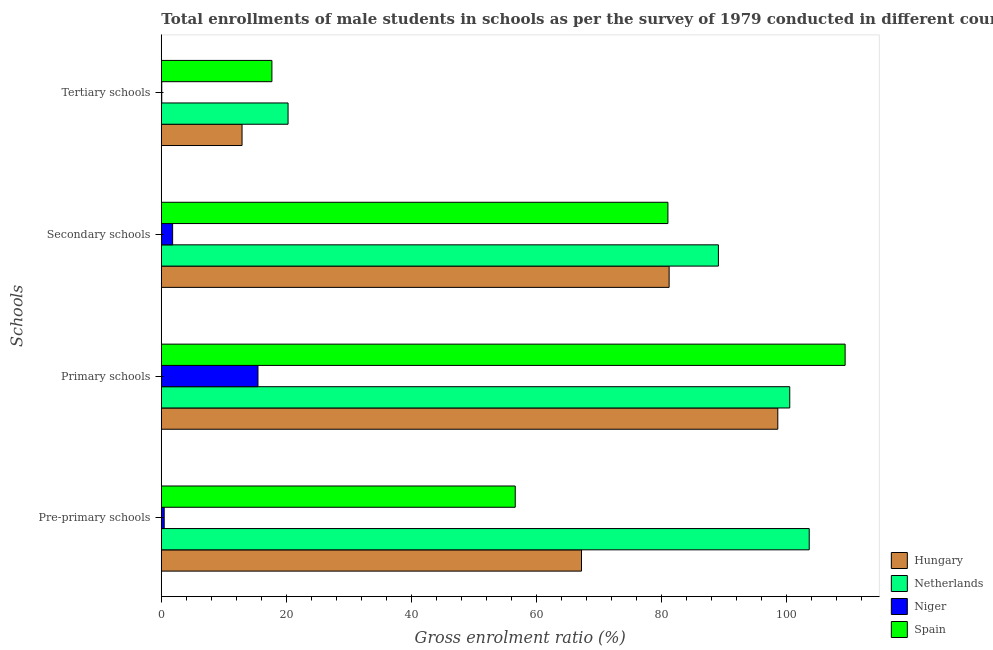How many different coloured bars are there?
Your answer should be compact. 4. Are the number of bars per tick equal to the number of legend labels?
Your response must be concise. Yes. How many bars are there on the 1st tick from the top?
Your answer should be very brief. 4. What is the label of the 4th group of bars from the top?
Offer a terse response. Pre-primary schools. What is the gross enrolment ratio(male) in primary schools in Netherlands?
Offer a very short reply. 100.51. Across all countries, what is the maximum gross enrolment ratio(male) in pre-primary schools?
Your response must be concise. 103.62. Across all countries, what is the minimum gross enrolment ratio(male) in primary schools?
Offer a terse response. 15.46. In which country was the gross enrolment ratio(male) in pre-primary schools maximum?
Provide a succinct answer. Netherlands. In which country was the gross enrolment ratio(male) in tertiary schools minimum?
Your answer should be very brief. Niger. What is the total gross enrolment ratio(male) in tertiary schools in the graph?
Offer a terse response. 50.94. What is the difference between the gross enrolment ratio(male) in primary schools in Netherlands and that in Niger?
Make the answer very short. 85.05. What is the difference between the gross enrolment ratio(male) in secondary schools in Spain and the gross enrolment ratio(male) in primary schools in Hungary?
Offer a very short reply. -17.57. What is the average gross enrolment ratio(male) in pre-primary schools per country?
Provide a succinct answer. 56.97. What is the difference between the gross enrolment ratio(male) in secondary schools and gross enrolment ratio(male) in primary schools in Netherlands?
Make the answer very short. -11.41. In how many countries, is the gross enrolment ratio(male) in secondary schools greater than 24 %?
Offer a terse response. 3. What is the ratio of the gross enrolment ratio(male) in secondary schools in Hungary to that in Netherlands?
Ensure brevity in your answer.  0.91. Is the gross enrolment ratio(male) in pre-primary schools in Hungary less than that in Niger?
Offer a very short reply. No. What is the difference between the highest and the second highest gross enrolment ratio(male) in tertiary schools?
Your answer should be very brief. 2.58. What is the difference between the highest and the lowest gross enrolment ratio(male) in tertiary schools?
Offer a very short reply. 20.2. In how many countries, is the gross enrolment ratio(male) in tertiary schools greater than the average gross enrolment ratio(male) in tertiary schools taken over all countries?
Your response must be concise. 3. Is the sum of the gross enrolment ratio(male) in pre-primary schools in Hungary and Netherlands greater than the maximum gross enrolment ratio(male) in secondary schools across all countries?
Your answer should be compact. Yes. What does the 3rd bar from the top in Secondary schools represents?
Provide a short and direct response. Netherlands. What does the 2nd bar from the bottom in Tertiary schools represents?
Give a very brief answer. Netherlands. How many bars are there?
Ensure brevity in your answer.  16. How many countries are there in the graph?
Give a very brief answer. 4. Does the graph contain any zero values?
Your answer should be very brief. No. Does the graph contain grids?
Give a very brief answer. No. Where does the legend appear in the graph?
Ensure brevity in your answer.  Bottom right. How many legend labels are there?
Your answer should be very brief. 4. What is the title of the graph?
Your answer should be very brief. Total enrollments of male students in schools as per the survey of 1979 conducted in different countries. Does "Denmark" appear as one of the legend labels in the graph?
Provide a short and direct response. No. What is the label or title of the Y-axis?
Give a very brief answer. Schools. What is the Gross enrolment ratio (%) in Hungary in Pre-primary schools?
Provide a succinct answer. 67.2. What is the Gross enrolment ratio (%) of Netherlands in Pre-primary schools?
Your answer should be compact. 103.62. What is the Gross enrolment ratio (%) of Niger in Pre-primary schools?
Offer a very short reply. 0.46. What is the Gross enrolment ratio (%) in Spain in Pre-primary schools?
Offer a very short reply. 56.6. What is the Gross enrolment ratio (%) in Hungary in Primary schools?
Your answer should be very brief. 98.6. What is the Gross enrolment ratio (%) of Netherlands in Primary schools?
Make the answer very short. 100.51. What is the Gross enrolment ratio (%) of Niger in Primary schools?
Provide a succinct answer. 15.46. What is the Gross enrolment ratio (%) in Spain in Primary schools?
Keep it short and to the point. 109.36. What is the Gross enrolment ratio (%) in Hungary in Secondary schools?
Your response must be concise. 81.22. What is the Gross enrolment ratio (%) of Netherlands in Secondary schools?
Your answer should be compact. 89.1. What is the Gross enrolment ratio (%) in Niger in Secondary schools?
Provide a short and direct response. 1.81. What is the Gross enrolment ratio (%) in Spain in Secondary schools?
Make the answer very short. 81.02. What is the Gross enrolment ratio (%) in Hungary in Tertiary schools?
Ensure brevity in your answer.  12.91. What is the Gross enrolment ratio (%) of Netherlands in Tertiary schools?
Make the answer very short. 20.27. What is the Gross enrolment ratio (%) of Niger in Tertiary schools?
Make the answer very short. 0.07. What is the Gross enrolment ratio (%) in Spain in Tertiary schools?
Keep it short and to the point. 17.69. Across all Schools, what is the maximum Gross enrolment ratio (%) of Hungary?
Your answer should be very brief. 98.6. Across all Schools, what is the maximum Gross enrolment ratio (%) in Netherlands?
Your response must be concise. 103.62. Across all Schools, what is the maximum Gross enrolment ratio (%) of Niger?
Your response must be concise. 15.46. Across all Schools, what is the maximum Gross enrolment ratio (%) of Spain?
Offer a terse response. 109.36. Across all Schools, what is the minimum Gross enrolment ratio (%) of Hungary?
Your response must be concise. 12.91. Across all Schools, what is the minimum Gross enrolment ratio (%) in Netherlands?
Make the answer very short. 20.27. Across all Schools, what is the minimum Gross enrolment ratio (%) in Niger?
Give a very brief answer. 0.07. Across all Schools, what is the minimum Gross enrolment ratio (%) of Spain?
Your answer should be compact. 17.69. What is the total Gross enrolment ratio (%) of Hungary in the graph?
Offer a terse response. 259.93. What is the total Gross enrolment ratio (%) in Netherlands in the graph?
Your response must be concise. 313.5. What is the total Gross enrolment ratio (%) in Niger in the graph?
Give a very brief answer. 17.8. What is the total Gross enrolment ratio (%) in Spain in the graph?
Ensure brevity in your answer.  264.68. What is the difference between the Gross enrolment ratio (%) of Hungary in Pre-primary schools and that in Primary schools?
Provide a short and direct response. -31.39. What is the difference between the Gross enrolment ratio (%) in Netherlands in Pre-primary schools and that in Primary schools?
Make the answer very short. 3.12. What is the difference between the Gross enrolment ratio (%) of Niger in Pre-primary schools and that in Primary schools?
Make the answer very short. -15. What is the difference between the Gross enrolment ratio (%) in Spain in Pre-primary schools and that in Primary schools?
Your answer should be very brief. -52.76. What is the difference between the Gross enrolment ratio (%) in Hungary in Pre-primary schools and that in Secondary schools?
Ensure brevity in your answer.  -14.01. What is the difference between the Gross enrolment ratio (%) of Netherlands in Pre-primary schools and that in Secondary schools?
Your answer should be compact. 14.53. What is the difference between the Gross enrolment ratio (%) in Niger in Pre-primary schools and that in Secondary schools?
Offer a very short reply. -1.35. What is the difference between the Gross enrolment ratio (%) in Spain in Pre-primary schools and that in Secondary schools?
Keep it short and to the point. -24.42. What is the difference between the Gross enrolment ratio (%) in Hungary in Pre-primary schools and that in Tertiary schools?
Keep it short and to the point. 54.29. What is the difference between the Gross enrolment ratio (%) in Netherlands in Pre-primary schools and that in Tertiary schools?
Offer a very short reply. 83.35. What is the difference between the Gross enrolment ratio (%) in Niger in Pre-primary schools and that in Tertiary schools?
Ensure brevity in your answer.  0.39. What is the difference between the Gross enrolment ratio (%) of Spain in Pre-primary schools and that in Tertiary schools?
Your response must be concise. 38.92. What is the difference between the Gross enrolment ratio (%) in Hungary in Primary schools and that in Secondary schools?
Your response must be concise. 17.38. What is the difference between the Gross enrolment ratio (%) of Netherlands in Primary schools and that in Secondary schools?
Ensure brevity in your answer.  11.41. What is the difference between the Gross enrolment ratio (%) of Niger in Primary schools and that in Secondary schools?
Keep it short and to the point. 13.65. What is the difference between the Gross enrolment ratio (%) of Spain in Primary schools and that in Secondary schools?
Provide a succinct answer. 28.34. What is the difference between the Gross enrolment ratio (%) of Hungary in Primary schools and that in Tertiary schools?
Give a very brief answer. 85.68. What is the difference between the Gross enrolment ratio (%) of Netherlands in Primary schools and that in Tertiary schools?
Keep it short and to the point. 80.24. What is the difference between the Gross enrolment ratio (%) in Niger in Primary schools and that in Tertiary schools?
Your answer should be very brief. 15.39. What is the difference between the Gross enrolment ratio (%) in Spain in Primary schools and that in Tertiary schools?
Keep it short and to the point. 91.68. What is the difference between the Gross enrolment ratio (%) of Hungary in Secondary schools and that in Tertiary schools?
Keep it short and to the point. 68.3. What is the difference between the Gross enrolment ratio (%) in Netherlands in Secondary schools and that in Tertiary schools?
Your answer should be compact. 68.83. What is the difference between the Gross enrolment ratio (%) in Niger in Secondary schools and that in Tertiary schools?
Your response must be concise. 1.74. What is the difference between the Gross enrolment ratio (%) in Spain in Secondary schools and that in Tertiary schools?
Ensure brevity in your answer.  63.33. What is the difference between the Gross enrolment ratio (%) of Hungary in Pre-primary schools and the Gross enrolment ratio (%) of Netherlands in Primary schools?
Provide a short and direct response. -33.3. What is the difference between the Gross enrolment ratio (%) in Hungary in Pre-primary schools and the Gross enrolment ratio (%) in Niger in Primary schools?
Provide a short and direct response. 51.74. What is the difference between the Gross enrolment ratio (%) of Hungary in Pre-primary schools and the Gross enrolment ratio (%) of Spain in Primary schools?
Give a very brief answer. -42.16. What is the difference between the Gross enrolment ratio (%) of Netherlands in Pre-primary schools and the Gross enrolment ratio (%) of Niger in Primary schools?
Offer a terse response. 88.16. What is the difference between the Gross enrolment ratio (%) of Netherlands in Pre-primary schools and the Gross enrolment ratio (%) of Spain in Primary schools?
Your answer should be compact. -5.74. What is the difference between the Gross enrolment ratio (%) in Niger in Pre-primary schools and the Gross enrolment ratio (%) in Spain in Primary schools?
Provide a short and direct response. -108.9. What is the difference between the Gross enrolment ratio (%) of Hungary in Pre-primary schools and the Gross enrolment ratio (%) of Netherlands in Secondary schools?
Provide a short and direct response. -21.9. What is the difference between the Gross enrolment ratio (%) of Hungary in Pre-primary schools and the Gross enrolment ratio (%) of Niger in Secondary schools?
Your response must be concise. 65.39. What is the difference between the Gross enrolment ratio (%) of Hungary in Pre-primary schools and the Gross enrolment ratio (%) of Spain in Secondary schools?
Make the answer very short. -13.82. What is the difference between the Gross enrolment ratio (%) in Netherlands in Pre-primary schools and the Gross enrolment ratio (%) in Niger in Secondary schools?
Keep it short and to the point. 101.81. What is the difference between the Gross enrolment ratio (%) in Netherlands in Pre-primary schools and the Gross enrolment ratio (%) in Spain in Secondary schools?
Your answer should be compact. 22.6. What is the difference between the Gross enrolment ratio (%) in Niger in Pre-primary schools and the Gross enrolment ratio (%) in Spain in Secondary schools?
Provide a short and direct response. -80.56. What is the difference between the Gross enrolment ratio (%) of Hungary in Pre-primary schools and the Gross enrolment ratio (%) of Netherlands in Tertiary schools?
Keep it short and to the point. 46.93. What is the difference between the Gross enrolment ratio (%) in Hungary in Pre-primary schools and the Gross enrolment ratio (%) in Niger in Tertiary schools?
Provide a short and direct response. 67.13. What is the difference between the Gross enrolment ratio (%) in Hungary in Pre-primary schools and the Gross enrolment ratio (%) in Spain in Tertiary schools?
Keep it short and to the point. 49.51. What is the difference between the Gross enrolment ratio (%) of Netherlands in Pre-primary schools and the Gross enrolment ratio (%) of Niger in Tertiary schools?
Keep it short and to the point. 103.55. What is the difference between the Gross enrolment ratio (%) of Netherlands in Pre-primary schools and the Gross enrolment ratio (%) of Spain in Tertiary schools?
Ensure brevity in your answer.  85.93. What is the difference between the Gross enrolment ratio (%) of Niger in Pre-primary schools and the Gross enrolment ratio (%) of Spain in Tertiary schools?
Make the answer very short. -17.23. What is the difference between the Gross enrolment ratio (%) of Hungary in Primary schools and the Gross enrolment ratio (%) of Netherlands in Secondary schools?
Keep it short and to the point. 9.5. What is the difference between the Gross enrolment ratio (%) in Hungary in Primary schools and the Gross enrolment ratio (%) in Niger in Secondary schools?
Give a very brief answer. 96.79. What is the difference between the Gross enrolment ratio (%) in Hungary in Primary schools and the Gross enrolment ratio (%) in Spain in Secondary schools?
Keep it short and to the point. 17.57. What is the difference between the Gross enrolment ratio (%) of Netherlands in Primary schools and the Gross enrolment ratio (%) of Niger in Secondary schools?
Ensure brevity in your answer.  98.7. What is the difference between the Gross enrolment ratio (%) of Netherlands in Primary schools and the Gross enrolment ratio (%) of Spain in Secondary schools?
Give a very brief answer. 19.49. What is the difference between the Gross enrolment ratio (%) of Niger in Primary schools and the Gross enrolment ratio (%) of Spain in Secondary schools?
Your response must be concise. -65.56. What is the difference between the Gross enrolment ratio (%) in Hungary in Primary schools and the Gross enrolment ratio (%) in Netherlands in Tertiary schools?
Make the answer very short. 78.32. What is the difference between the Gross enrolment ratio (%) of Hungary in Primary schools and the Gross enrolment ratio (%) of Niger in Tertiary schools?
Make the answer very short. 98.53. What is the difference between the Gross enrolment ratio (%) of Hungary in Primary schools and the Gross enrolment ratio (%) of Spain in Tertiary schools?
Provide a succinct answer. 80.91. What is the difference between the Gross enrolment ratio (%) of Netherlands in Primary schools and the Gross enrolment ratio (%) of Niger in Tertiary schools?
Your answer should be compact. 100.44. What is the difference between the Gross enrolment ratio (%) in Netherlands in Primary schools and the Gross enrolment ratio (%) in Spain in Tertiary schools?
Provide a succinct answer. 82.82. What is the difference between the Gross enrolment ratio (%) of Niger in Primary schools and the Gross enrolment ratio (%) of Spain in Tertiary schools?
Ensure brevity in your answer.  -2.23. What is the difference between the Gross enrolment ratio (%) in Hungary in Secondary schools and the Gross enrolment ratio (%) in Netherlands in Tertiary schools?
Your answer should be very brief. 60.95. What is the difference between the Gross enrolment ratio (%) of Hungary in Secondary schools and the Gross enrolment ratio (%) of Niger in Tertiary schools?
Make the answer very short. 81.15. What is the difference between the Gross enrolment ratio (%) of Hungary in Secondary schools and the Gross enrolment ratio (%) of Spain in Tertiary schools?
Make the answer very short. 63.53. What is the difference between the Gross enrolment ratio (%) in Netherlands in Secondary schools and the Gross enrolment ratio (%) in Niger in Tertiary schools?
Your response must be concise. 89.03. What is the difference between the Gross enrolment ratio (%) in Netherlands in Secondary schools and the Gross enrolment ratio (%) in Spain in Tertiary schools?
Ensure brevity in your answer.  71.41. What is the difference between the Gross enrolment ratio (%) in Niger in Secondary schools and the Gross enrolment ratio (%) in Spain in Tertiary schools?
Your answer should be very brief. -15.88. What is the average Gross enrolment ratio (%) of Hungary per Schools?
Your answer should be compact. 64.98. What is the average Gross enrolment ratio (%) in Netherlands per Schools?
Your answer should be compact. 78.37. What is the average Gross enrolment ratio (%) in Niger per Schools?
Offer a very short reply. 4.45. What is the average Gross enrolment ratio (%) of Spain per Schools?
Make the answer very short. 66.17. What is the difference between the Gross enrolment ratio (%) in Hungary and Gross enrolment ratio (%) in Netherlands in Pre-primary schools?
Make the answer very short. -36.42. What is the difference between the Gross enrolment ratio (%) of Hungary and Gross enrolment ratio (%) of Niger in Pre-primary schools?
Offer a very short reply. 66.74. What is the difference between the Gross enrolment ratio (%) in Hungary and Gross enrolment ratio (%) in Spain in Pre-primary schools?
Your answer should be very brief. 10.6. What is the difference between the Gross enrolment ratio (%) of Netherlands and Gross enrolment ratio (%) of Niger in Pre-primary schools?
Provide a succinct answer. 103.16. What is the difference between the Gross enrolment ratio (%) of Netherlands and Gross enrolment ratio (%) of Spain in Pre-primary schools?
Give a very brief answer. 47.02. What is the difference between the Gross enrolment ratio (%) in Niger and Gross enrolment ratio (%) in Spain in Pre-primary schools?
Ensure brevity in your answer.  -56.14. What is the difference between the Gross enrolment ratio (%) of Hungary and Gross enrolment ratio (%) of Netherlands in Primary schools?
Make the answer very short. -1.91. What is the difference between the Gross enrolment ratio (%) of Hungary and Gross enrolment ratio (%) of Niger in Primary schools?
Your response must be concise. 83.14. What is the difference between the Gross enrolment ratio (%) in Hungary and Gross enrolment ratio (%) in Spain in Primary schools?
Offer a very short reply. -10.77. What is the difference between the Gross enrolment ratio (%) of Netherlands and Gross enrolment ratio (%) of Niger in Primary schools?
Provide a succinct answer. 85.05. What is the difference between the Gross enrolment ratio (%) in Netherlands and Gross enrolment ratio (%) in Spain in Primary schools?
Your answer should be compact. -8.86. What is the difference between the Gross enrolment ratio (%) of Niger and Gross enrolment ratio (%) of Spain in Primary schools?
Keep it short and to the point. -93.91. What is the difference between the Gross enrolment ratio (%) in Hungary and Gross enrolment ratio (%) in Netherlands in Secondary schools?
Your answer should be very brief. -7.88. What is the difference between the Gross enrolment ratio (%) of Hungary and Gross enrolment ratio (%) of Niger in Secondary schools?
Your answer should be compact. 79.41. What is the difference between the Gross enrolment ratio (%) of Hungary and Gross enrolment ratio (%) of Spain in Secondary schools?
Your answer should be very brief. 0.2. What is the difference between the Gross enrolment ratio (%) in Netherlands and Gross enrolment ratio (%) in Niger in Secondary schools?
Give a very brief answer. 87.29. What is the difference between the Gross enrolment ratio (%) of Netherlands and Gross enrolment ratio (%) of Spain in Secondary schools?
Provide a succinct answer. 8.08. What is the difference between the Gross enrolment ratio (%) in Niger and Gross enrolment ratio (%) in Spain in Secondary schools?
Your answer should be very brief. -79.21. What is the difference between the Gross enrolment ratio (%) of Hungary and Gross enrolment ratio (%) of Netherlands in Tertiary schools?
Your response must be concise. -7.36. What is the difference between the Gross enrolment ratio (%) of Hungary and Gross enrolment ratio (%) of Niger in Tertiary schools?
Provide a succinct answer. 12.84. What is the difference between the Gross enrolment ratio (%) in Hungary and Gross enrolment ratio (%) in Spain in Tertiary schools?
Your answer should be very brief. -4.78. What is the difference between the Gross enrolment ratio (%) in Netherlands and Gross enrolment ratio (%) in Niger in Tertiary schools?
Your answer should be very brief. 20.2. What is the difference between the Gross enrolment ratio (%) in Netherlands and Gross enrolment ratio (%) in Spain in Tertiary schools?
Ensure brevity in your answer.  2.58. What is the difference between the Gross enrolment ratio (%) in Niger and Gross enrolment ratio (%) in Spain in Tertiary schools?
Your response must be concise. -17.62. What is the ratio of the Gross enrolment ratio (%) in Hungary in Pre-primary schools to that in Primary schools?
Offer a very short reply. 0.68. What is the ratio of the Gross enrolment ratio (%) in Netherlands in Pre-primary schools to that in Primary schools?
Provide a succinct answer. 1.03. What is the ratio of the Gross enrolment ratio (%) of Niger in Pre-primary schools to that in Primary schools?
Ensure brevity in your answer.  0.03. What is the ratio of the Gross enrolment ratio (%) in Spain in Pre-primary schools to that in Primary schools?
Provide a short and direct response. 0.52. What is the ratio of the Gross enrolment ratio (%) in Hungary in Pre-primary schools to that in Secondary schools?
Offer a terse response. 0.83. What is the ratio of the Gross enrolment ratio (%) of Netherlands in Pre-primary schools to that in Secondary schools?
Offer a terse response. 1.16. What is the ratio of the Gross enrolment ratio (%) of Niger in Pre-primary schools to that in Secondary schools?
Offer a very short reply. 0.25. What is the ratio of the Gross enrolment ratio (%) of Spain in Pre-primary schools to that in Secondary schools?
Your response must be concise. 0.7. What is the ratio of the Gross enrolment ratio (%) in Hungary in Pre-primary schools to that in Tertiary schools?
Your answer should be compact. 5.2. What is the ratio of the Gross enrolment ratio (%) in Netherlands in Pre-primary schools to that in Tertiary schools?
Keep it short and to the point. 5.11. What is the ratio of the Gross enrolment ratio (%) in Niger in Pre-primary schools to that in Tertiary schools?
Provide a succinct answer. 6.59. What is the ratio of the Gross enrolment ratio (%) in Spain in Pre-primary schools to that in Tertiary schools?
Offer a very short reply. 3.2. What is the ratio of the Gross enrolment ratio (%) of Hungary in Primary schools to that in Secondary schools?
Make the answer very short. 1.21. What is the ratio of the Gross enrolment ratio (%) of Netherlands in Primary schools to that in Secondary schools?
Ensure brevity in your answer.  1.13. What is the ratio of the Gross enrolment ratio (%) of Niger in Primary schools to that in Secondary schools?
Offer a terse response. 8.55. What is the ratio of the Gross enrolment ratio (%) in Spain in Primary schools to that in Secondary schools?
Provide a short and direct response. 1.35. What is the ratio of the Gross enrolment ratio (%) in Hungary in Primary schools to that in Tertiary schools?
Your response must be concise. 7.64. What is the ratio of the Gross enrolment ratio (%) in Netherlands in Primary schools to that in Tertiary schools?
Make the answer very short. 4.96. What is the ratio of the Gross enrolment ratio (%) in Niger in Primary schools to that in Tertiary schools?
Make the answer very short. 221.01. What is the ratio of the Gross enrolment ratio (%) in Spain in Primary schools to that in Tertiary schools?
Your answer should be compact. 6.18. What is the ratio of the Gross enrolment ratio (%) of Hungary in Secondary schools to that in Tertiary schools?
Make the answer very short. 6.29. What is the ratio of the Gross enrolment ratio (%) of Netherlands in Secondary schools to that in Tertiary schools?
Offer a very short reply. 4.4. What is the ratio of the Gross enrolment ratio (%) in Niger in Secondary schools to that in Tertiary schools?
Give a very brief answer. 25.86. What is the ratio of the Gross enrolment ratio (%) in Spain in Secondary schools to that in Tertiary schools?
Provide a succinct answer. 4.58. What is the difference between the highest and the second highest Gross enrolment ratio (%) in Hungary?
Your answer should be compact. 17.38. What is the difference between the highest and the second highest Gross enrolment ratio (%) in Netherlands?
Your answer should be very brief. 3.12. What is the difference between the highest and the second highest Gross enrolment ratio (%) of Niger?
Give a very brief answer. 13.65. What is the difference between the highest and the second highest Gross enrolment ratio (%) of Spain?
Your answer should be very brief. 28.34. What is the difference between the highest and the lowest Gross enrolment ratio (%) in Hungary?
Provide a succinct answer. 85.68. What is the difference between the highest and the lowest Gross enrolment ratio (%) of Netherlands?
Ensure brevity in your answer.  83.35. What is the difference between the highest and the lowest Gross enrolment ratio (%) in Niger?
Your response must be concise. 15.39. What is the difference between the highest and the lowest Gross enrolment ratio (%) of Spain?
Give a very brief answer. 91.68. 